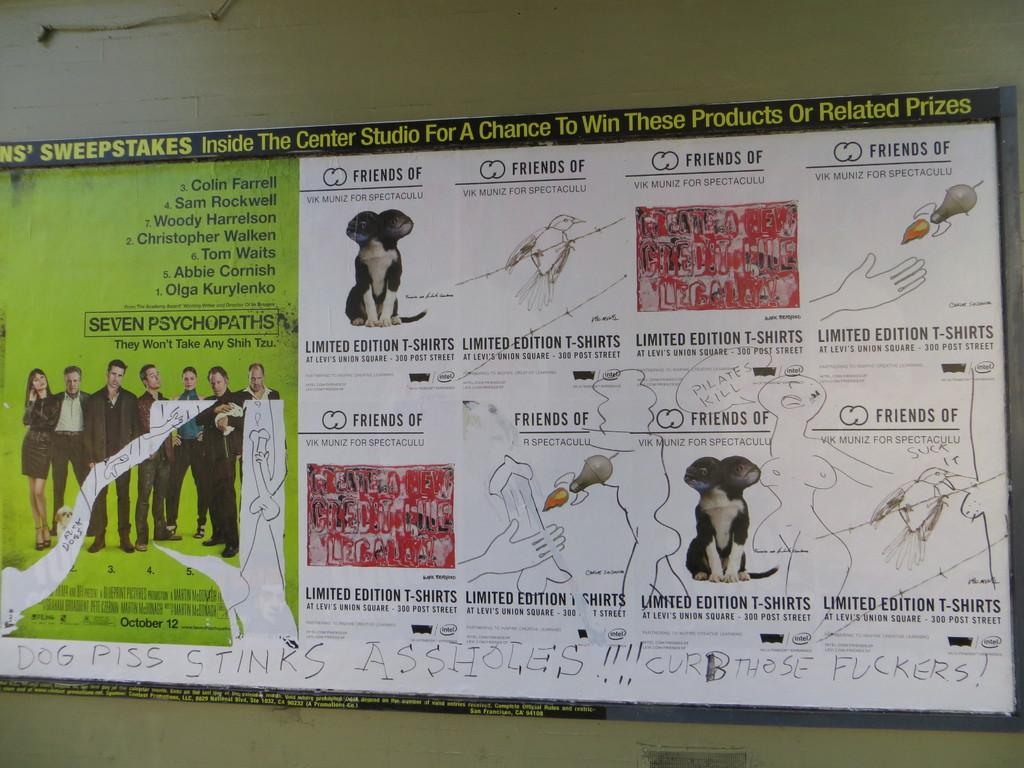<image>
Summarize the visual content of the image. A poster informing people about a sweepstakes and the prizes that can be won. 